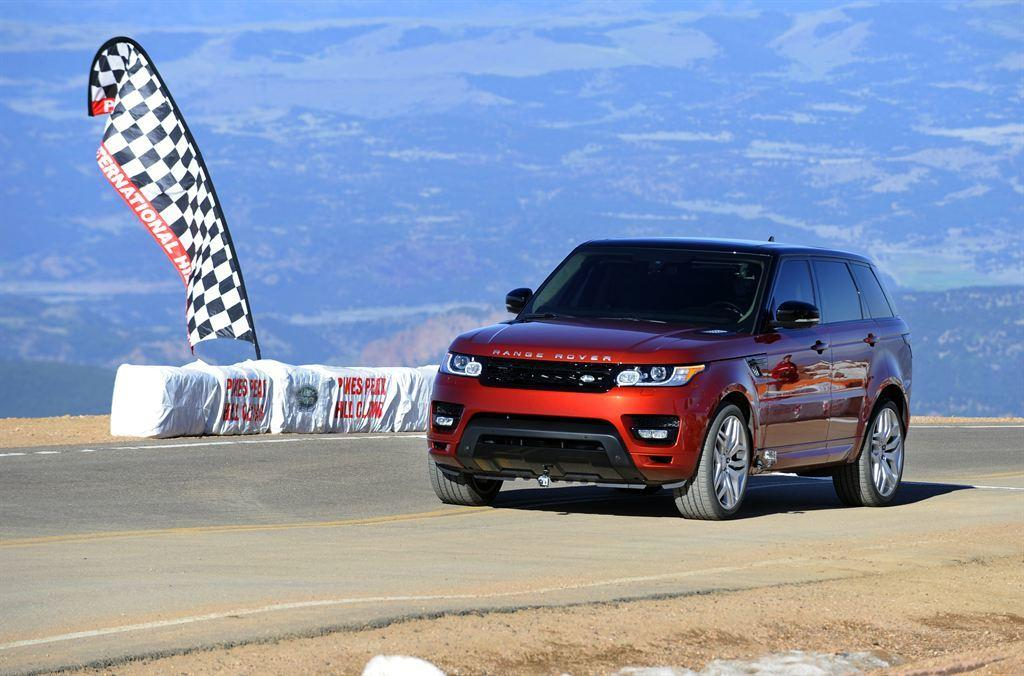What color is the car that is visible on the right side of the image? The car is red. Where is the red car located in the image? The red car is on the road. What can be seen on the left side of the image? There is a black and white flag on the left side of the image. What type of pleasure can be seen laughing in the image? There is no person or object in the image that can be associated with laughter or pleasure. 